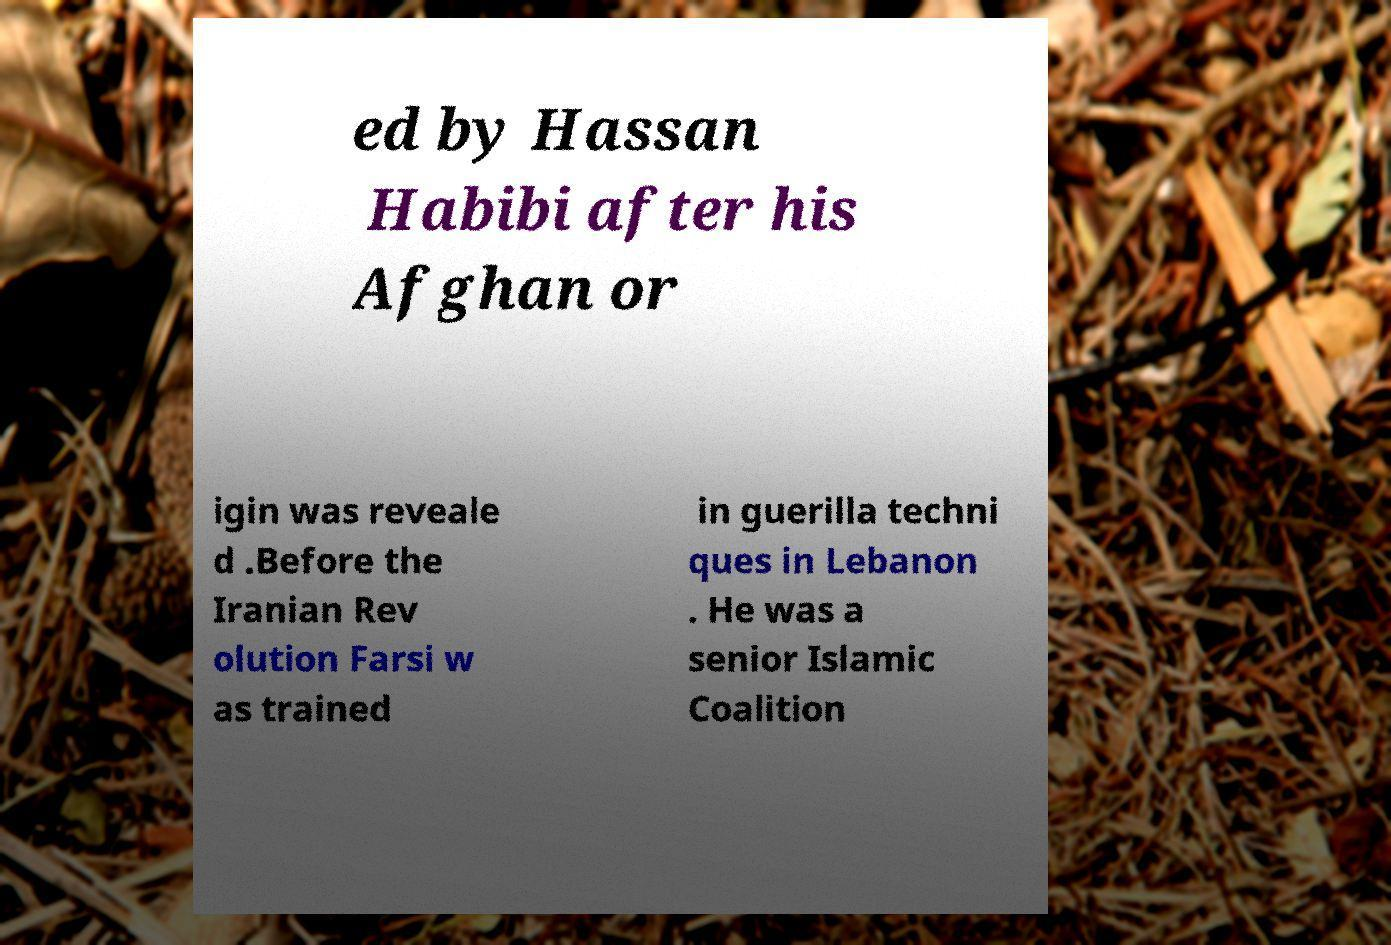I need the written content from this picture converted into text. Can you do that? ed by Hassan Habibi after his Afghan or igin was reveale d .Before the Iranian Rev olution Farsi w as trained in guerilla techni ques in Lebanon . He was a senior Islamic Coalition 